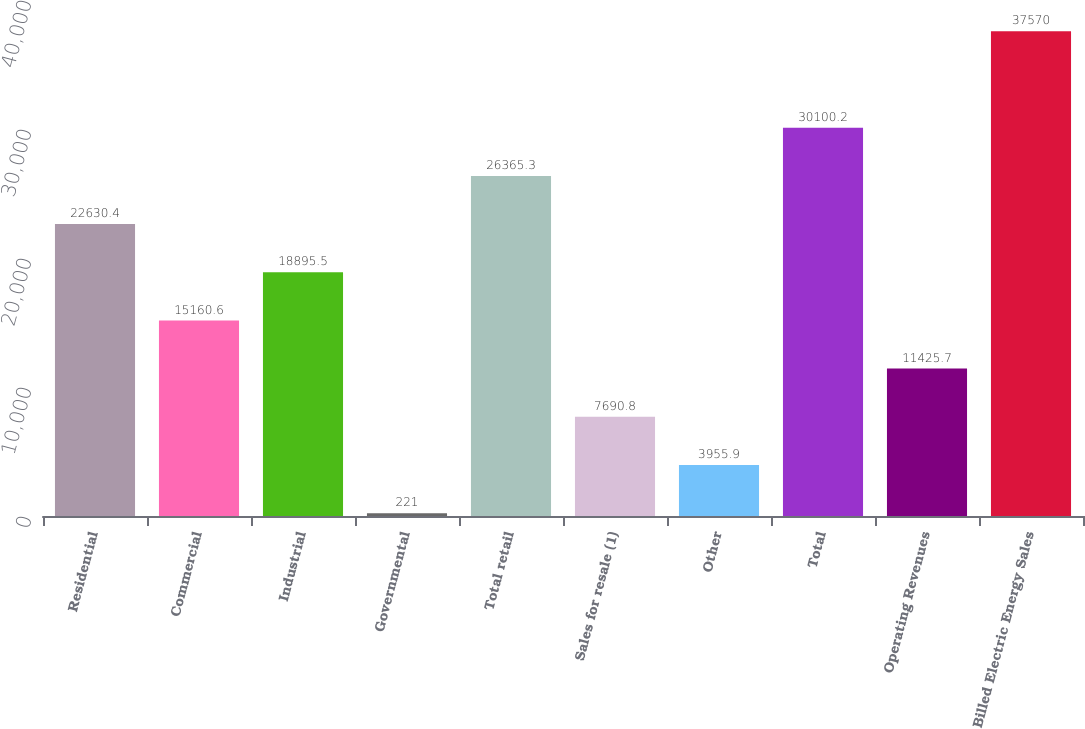Convert chart. <chart><loc_0><loc_0><loc_500><loc_500><bar_chart><fcel>Residential<fcel>Commercial<fcel>Industrial<fcel>Governmental<fcel>Total retail<fcel>Sales for resale (1)<fcel>Other<fcel>Total<fcel>Operating Revenues<fcel>Billed Electric Energy Sales<nl><fcel>22630.4<fcel>15160.6<fcel>18895.5<fcel>221<fcel>26365.3<fcel>7690.8<fcel>3955.9<fcel>30100.2<fcel>11425.7<fcel>37570<nl></chart> 